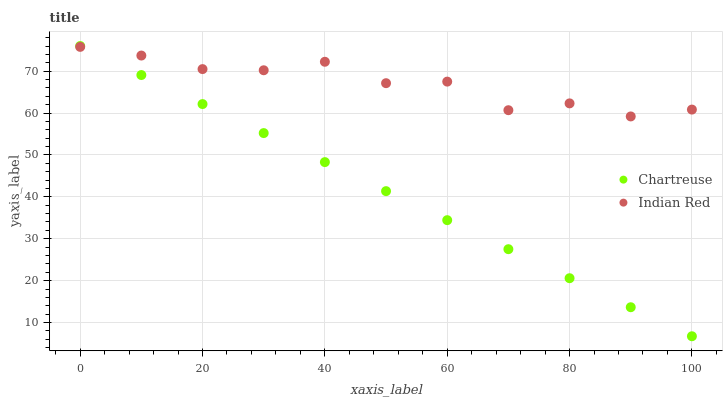Does Chartreuse have the minimum area under the curve?
Answer yes or no. Yes. Does Indian Red have the maximum area under the curve?
Answer yes or no. Yes. Does Indian Red have the minimum area under the curve?
Answer yes or no. No. Is Chartreuse the smoothest?
Answer yes or no. Yes. Is Indian Red the roughest?
Answer yes or no. Yes. Is Indian Red the smoothest?
Answer yes or no. No. Does Chartreuse have the lowest value?
Answer yes or no. Yes. Does Indian Red have the lowest value?
Answer yes or no. No. Does Chartreuse have the highest value?
Answer yes or no. Yes. Does Indian Red have the highest value?
Answer yes or no. No. Does Chartreuse intersect Indian Red?
Answer yes or no. Yes. Is Chartreuse less than Indian Red?
Answer yes or no. No. Is Chartreuse greater than Indian Red?
Answer yes or no. No. 